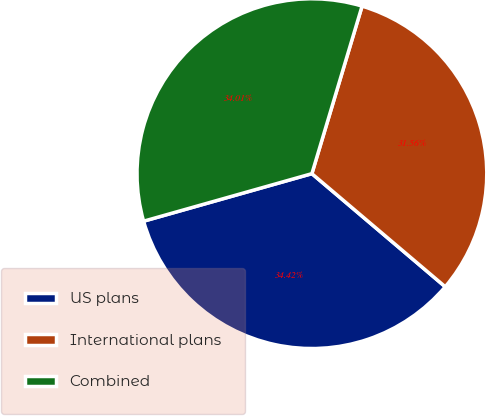Convert chart to OTSL. <chart><loc_0><loc_0><loc_500><loc_500><pie_chart><fcel>US plans<fcel>International plans<fcel>Combined<nl><fcel>34.42%<fcel>31.56%<fcel>34.01%<nl></chart> 